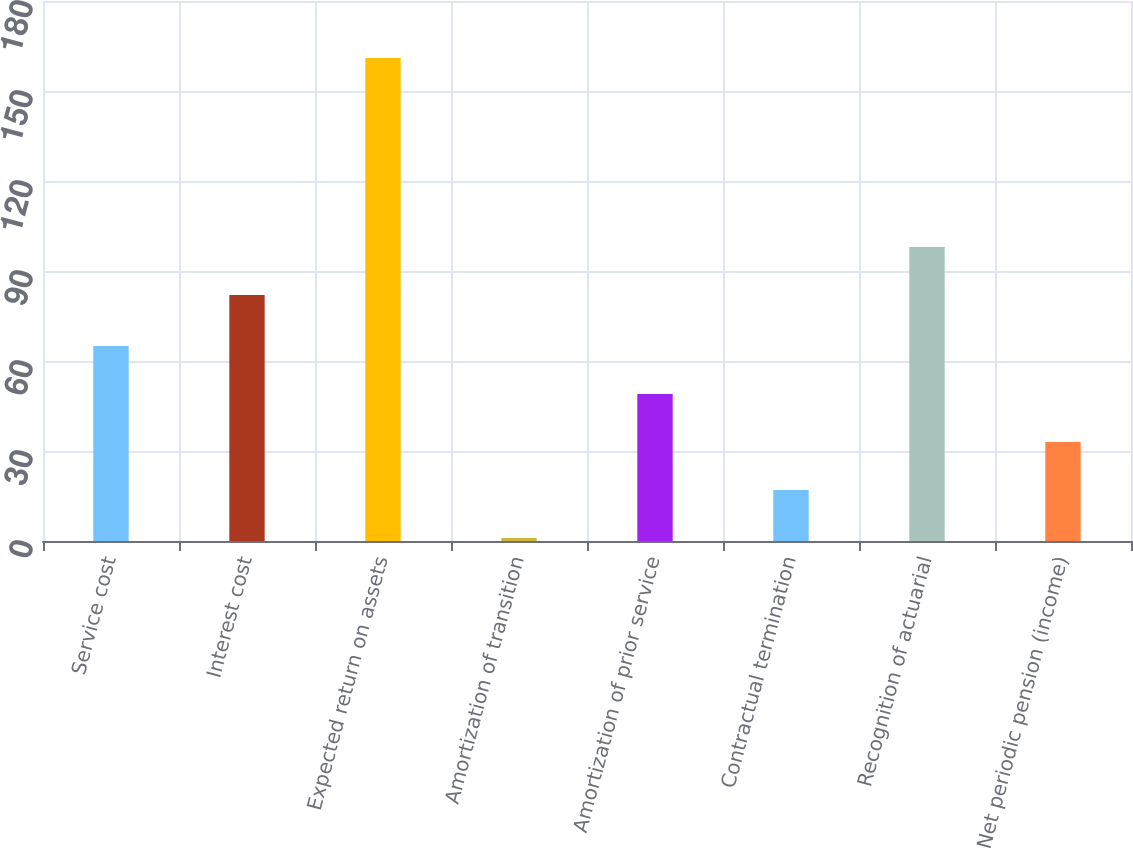<chart> <loc_0><loc_0><loc_500><loc_500><bar_chart><fcel>Service cost<fcel>Interest cost<fcel>Expected return on assets<fcel>Amortization of transition<fcel>Amortization of prior service<fcel>Contractual termination<fcel>Recognition of actuarial<fcel>Net periodic pension (income)<nl><fcel>65<fcel>82<fcel>161<fcel>1<fcel>49<fcel>17<fcel>98<fcel>33<nl></chart> 